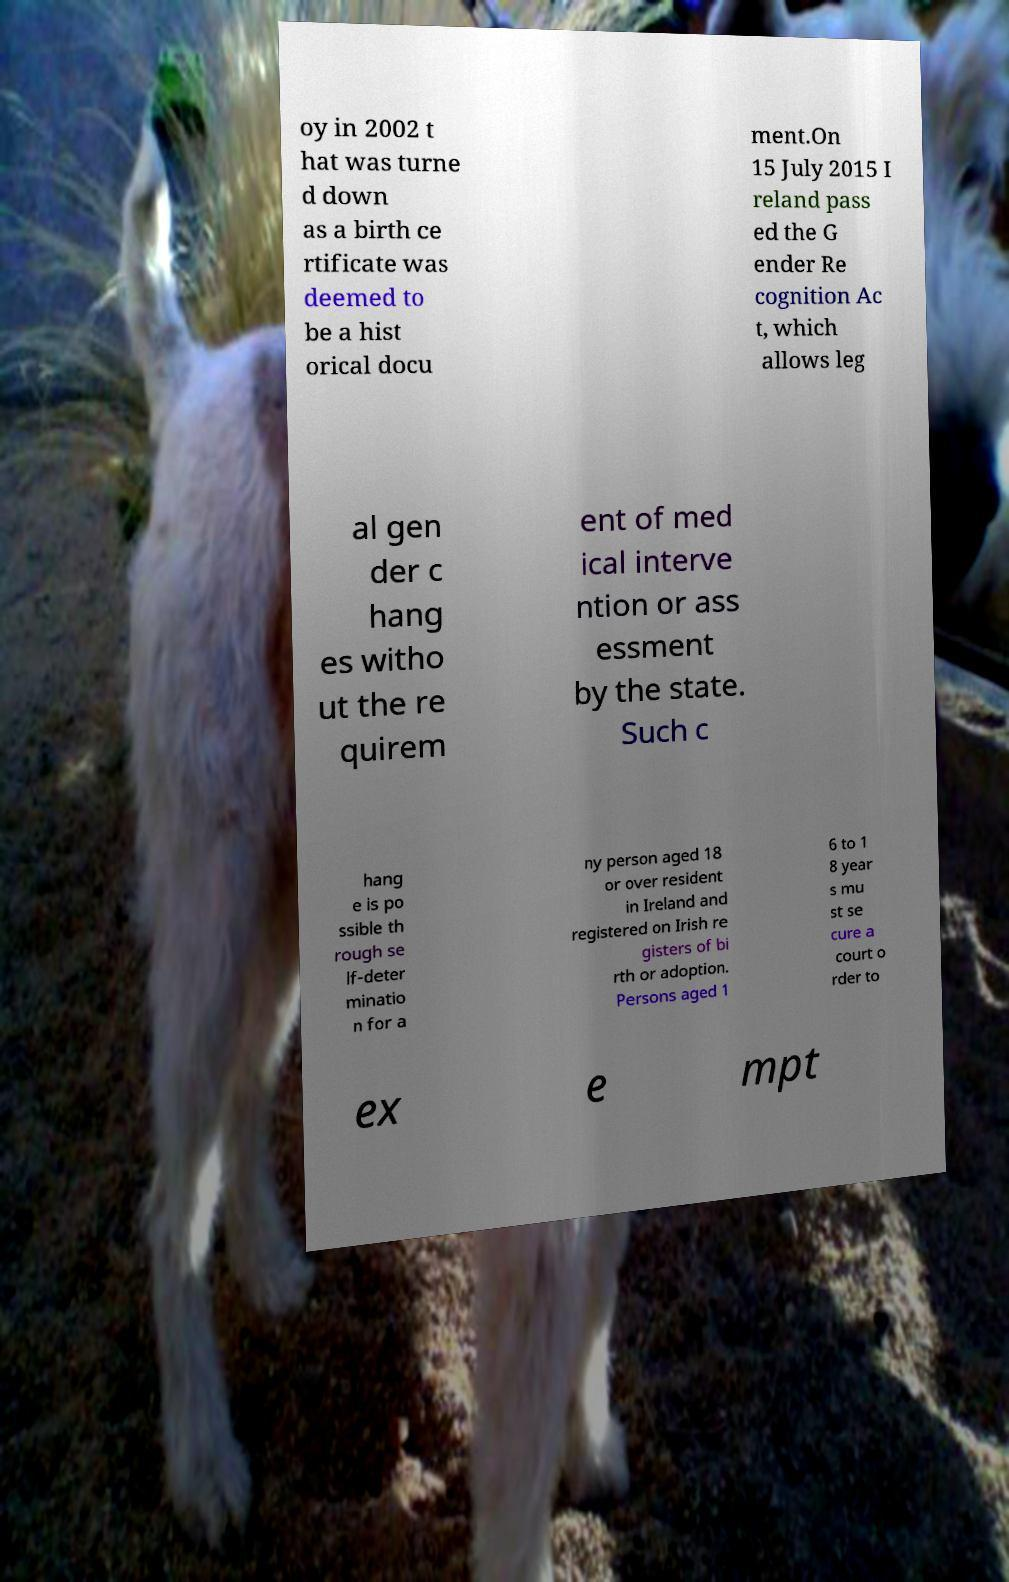Please read and relay the text visible in this image. What does it say? oy in 2002 t hat was turne d down as a birth ce rtificate was deemed to be a hist orical docu ment.On 15 July 2015 I reland pass ed the G ender Re cognition Ac t, which allows leg al gen der c hang es witho ut the re quirem ent of med ical interve ntion or ass essment by the state. Such c hang e is po ssible th rough se lf-deter minatio n for a ny person aged 18 or over resident in Ireland and registered on Irish re gisters of bi rth or adoption. Persons aged 1 6 to 1 8 year s mu st se cure a court o rder to ex e mpt 